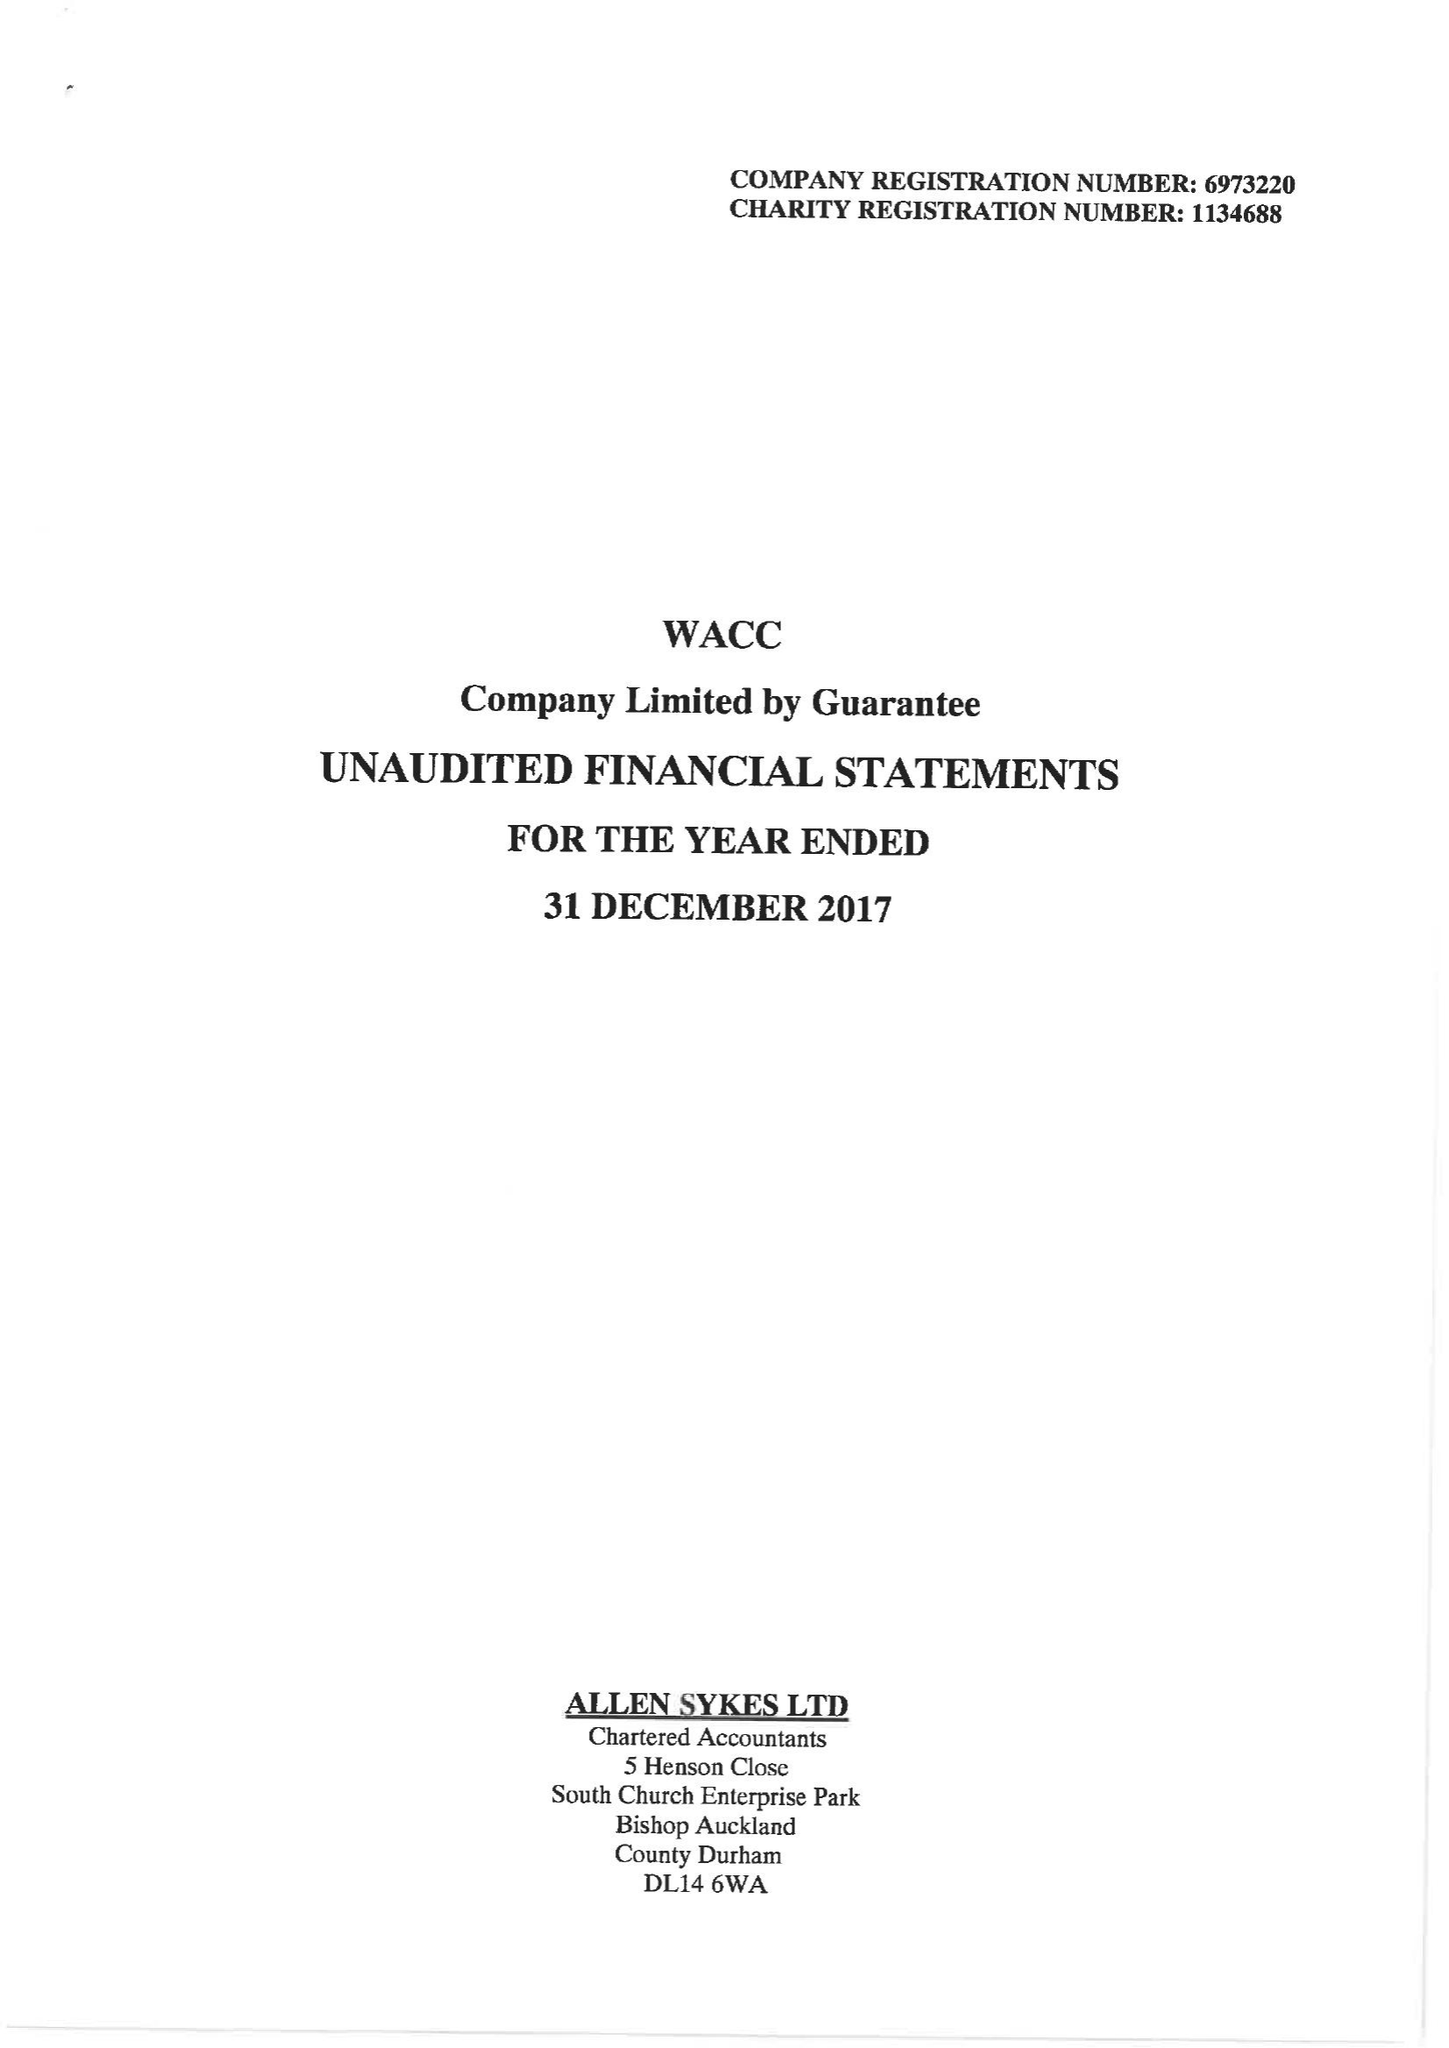What is the value for the charity_number?
Answer the question using a single word or phrase. 1134688 